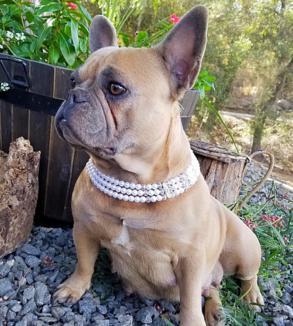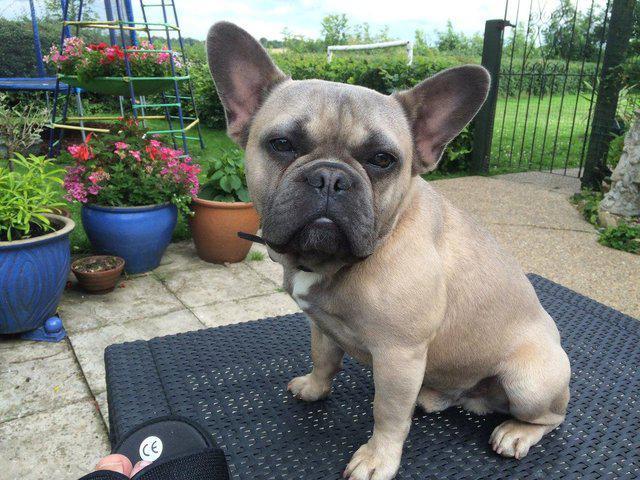The first image is the image on the left, the second image is the image on the right. For the images displayed, is the sentence "One of the dogs has their tongue out at least a little bit." factually correct? Answer yes or no. No. 